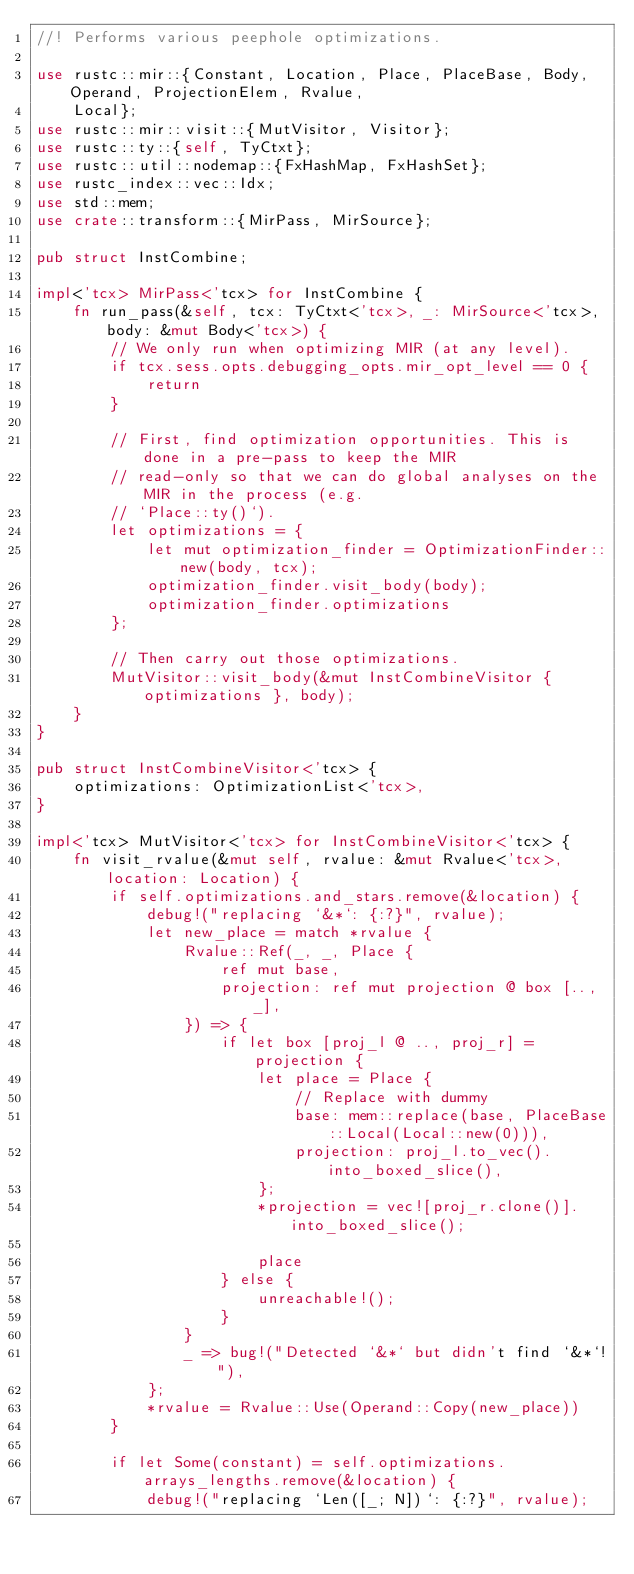<code> <loc_0><loc_0><loc_500><loc_500><_Rust_>//! Performs various peephole optimizations.

use rustc::mir::{Constant, Location, Place, PlaceBase, Body, Operand, ProjectionElem, Rvalue,
    Local};
use rustc::mir::visit::{MutVisitor, Visitor};
use rustc::ty::{self, TyCtxt};
use rustc::util::nodemap::{FxHashMap, FxHashSet};
use rustc_index::vec::Idx;
use std::mem;
use crate::transform::{MirPass, MirSource};

pub struct InstCombine;

impl<'tcx> MirPass<'tcx> for InstCombine {
    fn run_pass(&self, tcx: TyCtxt<'tcx>, _: MirSource<'tcx>, body: &mut Body<'tcx>) {
        // We only run when optimizing MIR (at any level).
        if tcx.sess.opts.debugging_opts.mir_opt_level == 0 {
            return
        }

        // First, find optimization opportunities. This is done in a pre-pass to keep the MIR
        // read-only so that we can do global analyses on the MIR in the process (e.g.
        // `Place::ty()`).
        let optimizations = {
            let mut optimization_finder = OptimizationFinder::new(body, tcx);
            optimization_finder.visit_body(body);
            optimization_finder.optimizations
        };

        // Then carry out those optimizations.
        MutVisitor::visit_body(&mut InstCombineVisitor { optimizations }, body);
    }
}

pub struct InstCombineVisitor<'tcx> {
    optimizations: OptimizationList<'tcx>,
}

impl<'tcx> MutVisitor<'tcx> for InstCombineVisitor<'tcx> {
    fn visit_rvalue(&mut self, rvalue: &mut Rvalue<'tcx>, location: Location) {
        if self.optimizations.and_stars.remove(&location) {
            debug!("replacing `&*`: {:?}", rvalue);
            let new_place = match *rvalue {
                Rvalue::Ref(_, _, Place {
                    ref mut base,
                    projection: ref mut projection @ box [.., _],
                }) => {
                    if let box [proj_l @ .., proj_r] = projection {
                        let place = Place {
                            // Replace with dummy
                            base: mem::replace(base, PlaceBase::Local(Local::new(0))),
                            projection: proj_l.to_vec().into_boxed_slice(),
                        };
                        *projection = vec![proj_r.clone()].into_boxed_slice();

                        place
                    } else {
                        unreachable!();
                    }
                }
                _ => bug!("Detected `&*` but didn't find `&*`!"),
            };
            *rvalue = Rvalue::Use(Operand::Copy(new_place))
        }

        if let Some(constant) = self.optimizations.arrays_lengths.remove(&location) {
            debug!("replacing `Len([_; N])`: {:?}", rvalue);</code> 